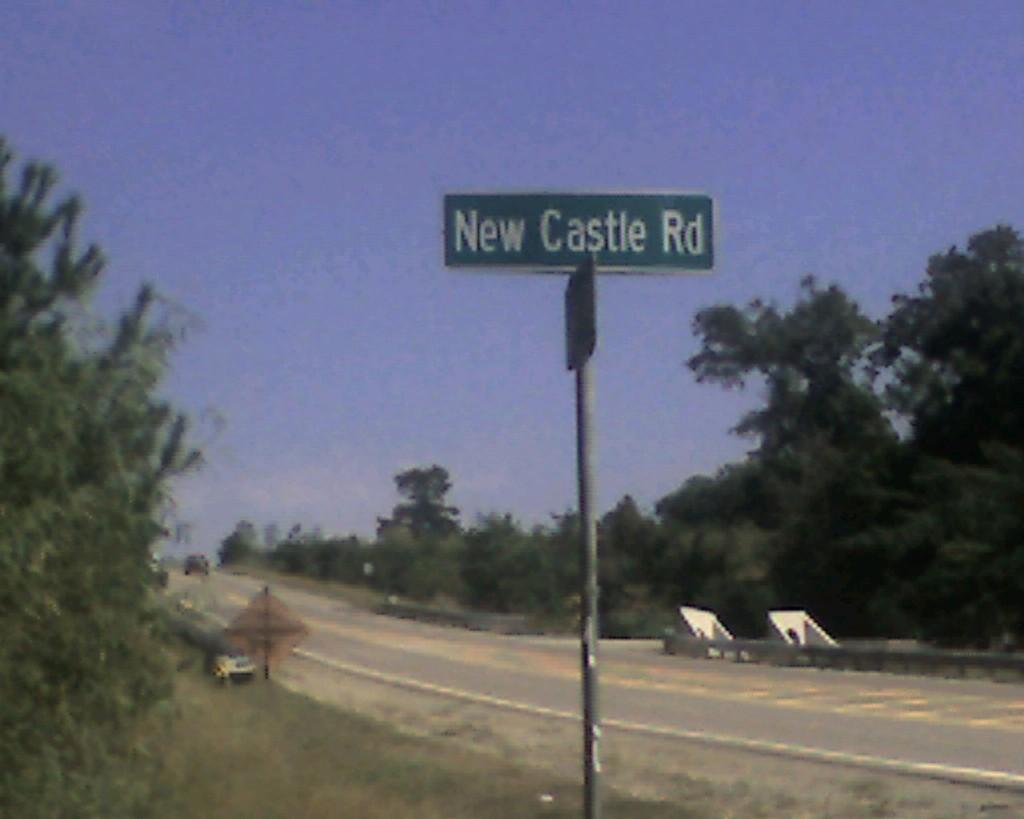What objects are present in the image that have both boards and poles? There are boards with poles in the image. What type of transportation can be seen on the road in the image? There is a vehicle on the road in the image. What type of natural vegetation is visible in the image? There are trees visible in the image. What part of the natural environment is visible in the background of the image? The sky is visible in the background of the image. What type of cough medicine is visible on the boards with poles in the image? There is no cough medicine present on the boards with poles in the image. 